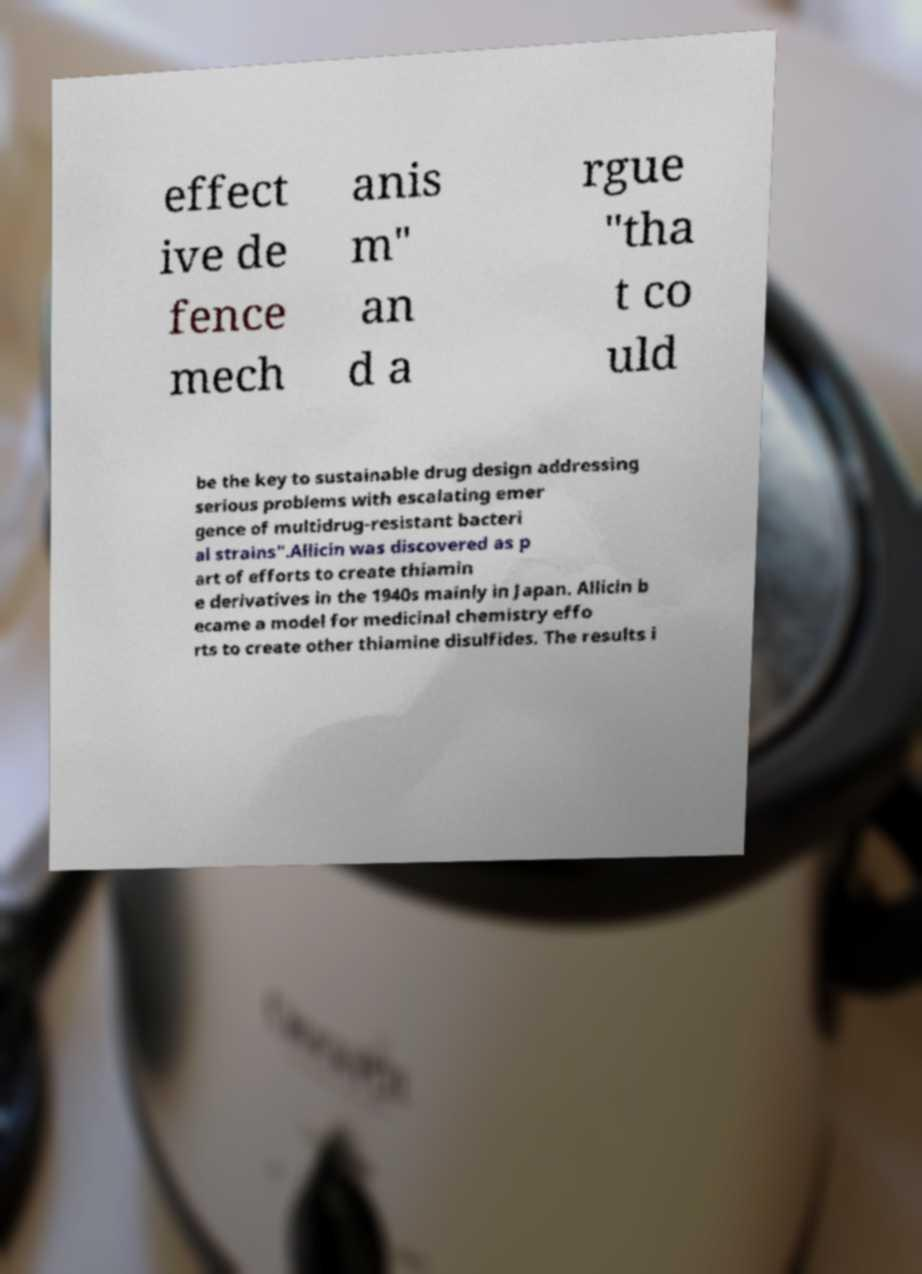Please identify and transcribe the text found in this image. effect ive de fence mech anis m" an d a rgue "tha t co uld be the key to sustainable drug design addressing serious problems with escalating emer gence of multidrug-resistant bacteri al strains".Allicin was discovered as p art of efforts to create thiamin e derivatives in the 1940s mainly in Japan. Allicin b ecame a model for medicinal chemistry effo rts to create other thiamine disulfides. The results i 